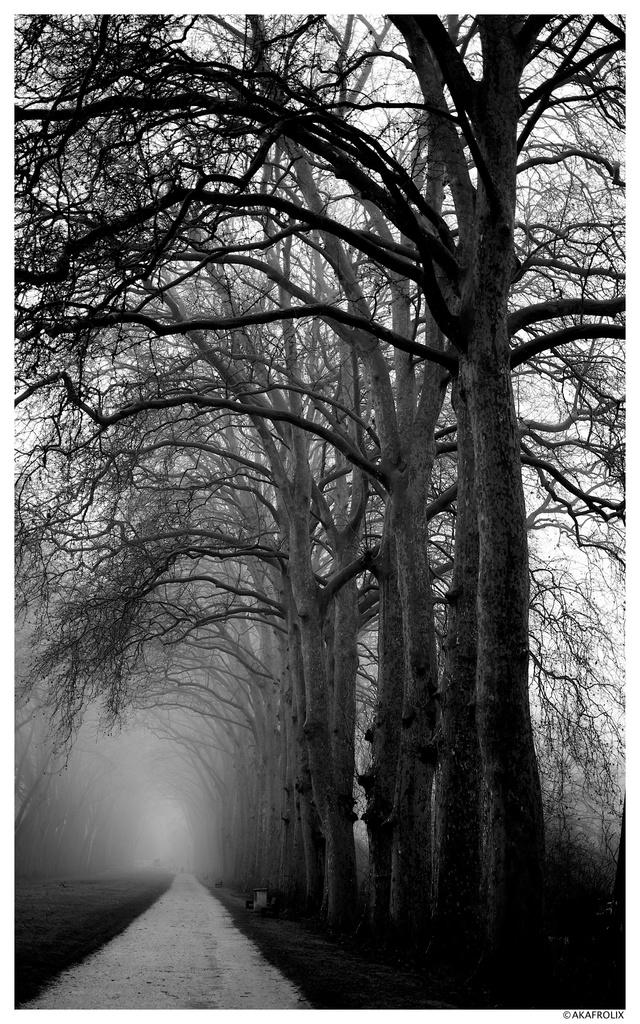What is located in the middle of the image? There are trees in the middle of the image. What is visible at the top of the image? The sky is visible at the top of the image. What color scheme is used in the image? The image is in black and white color. Can you see a bun in the image? There is no bun present in the image. Is there a snake visible in the image? There is no snake present in the image. 